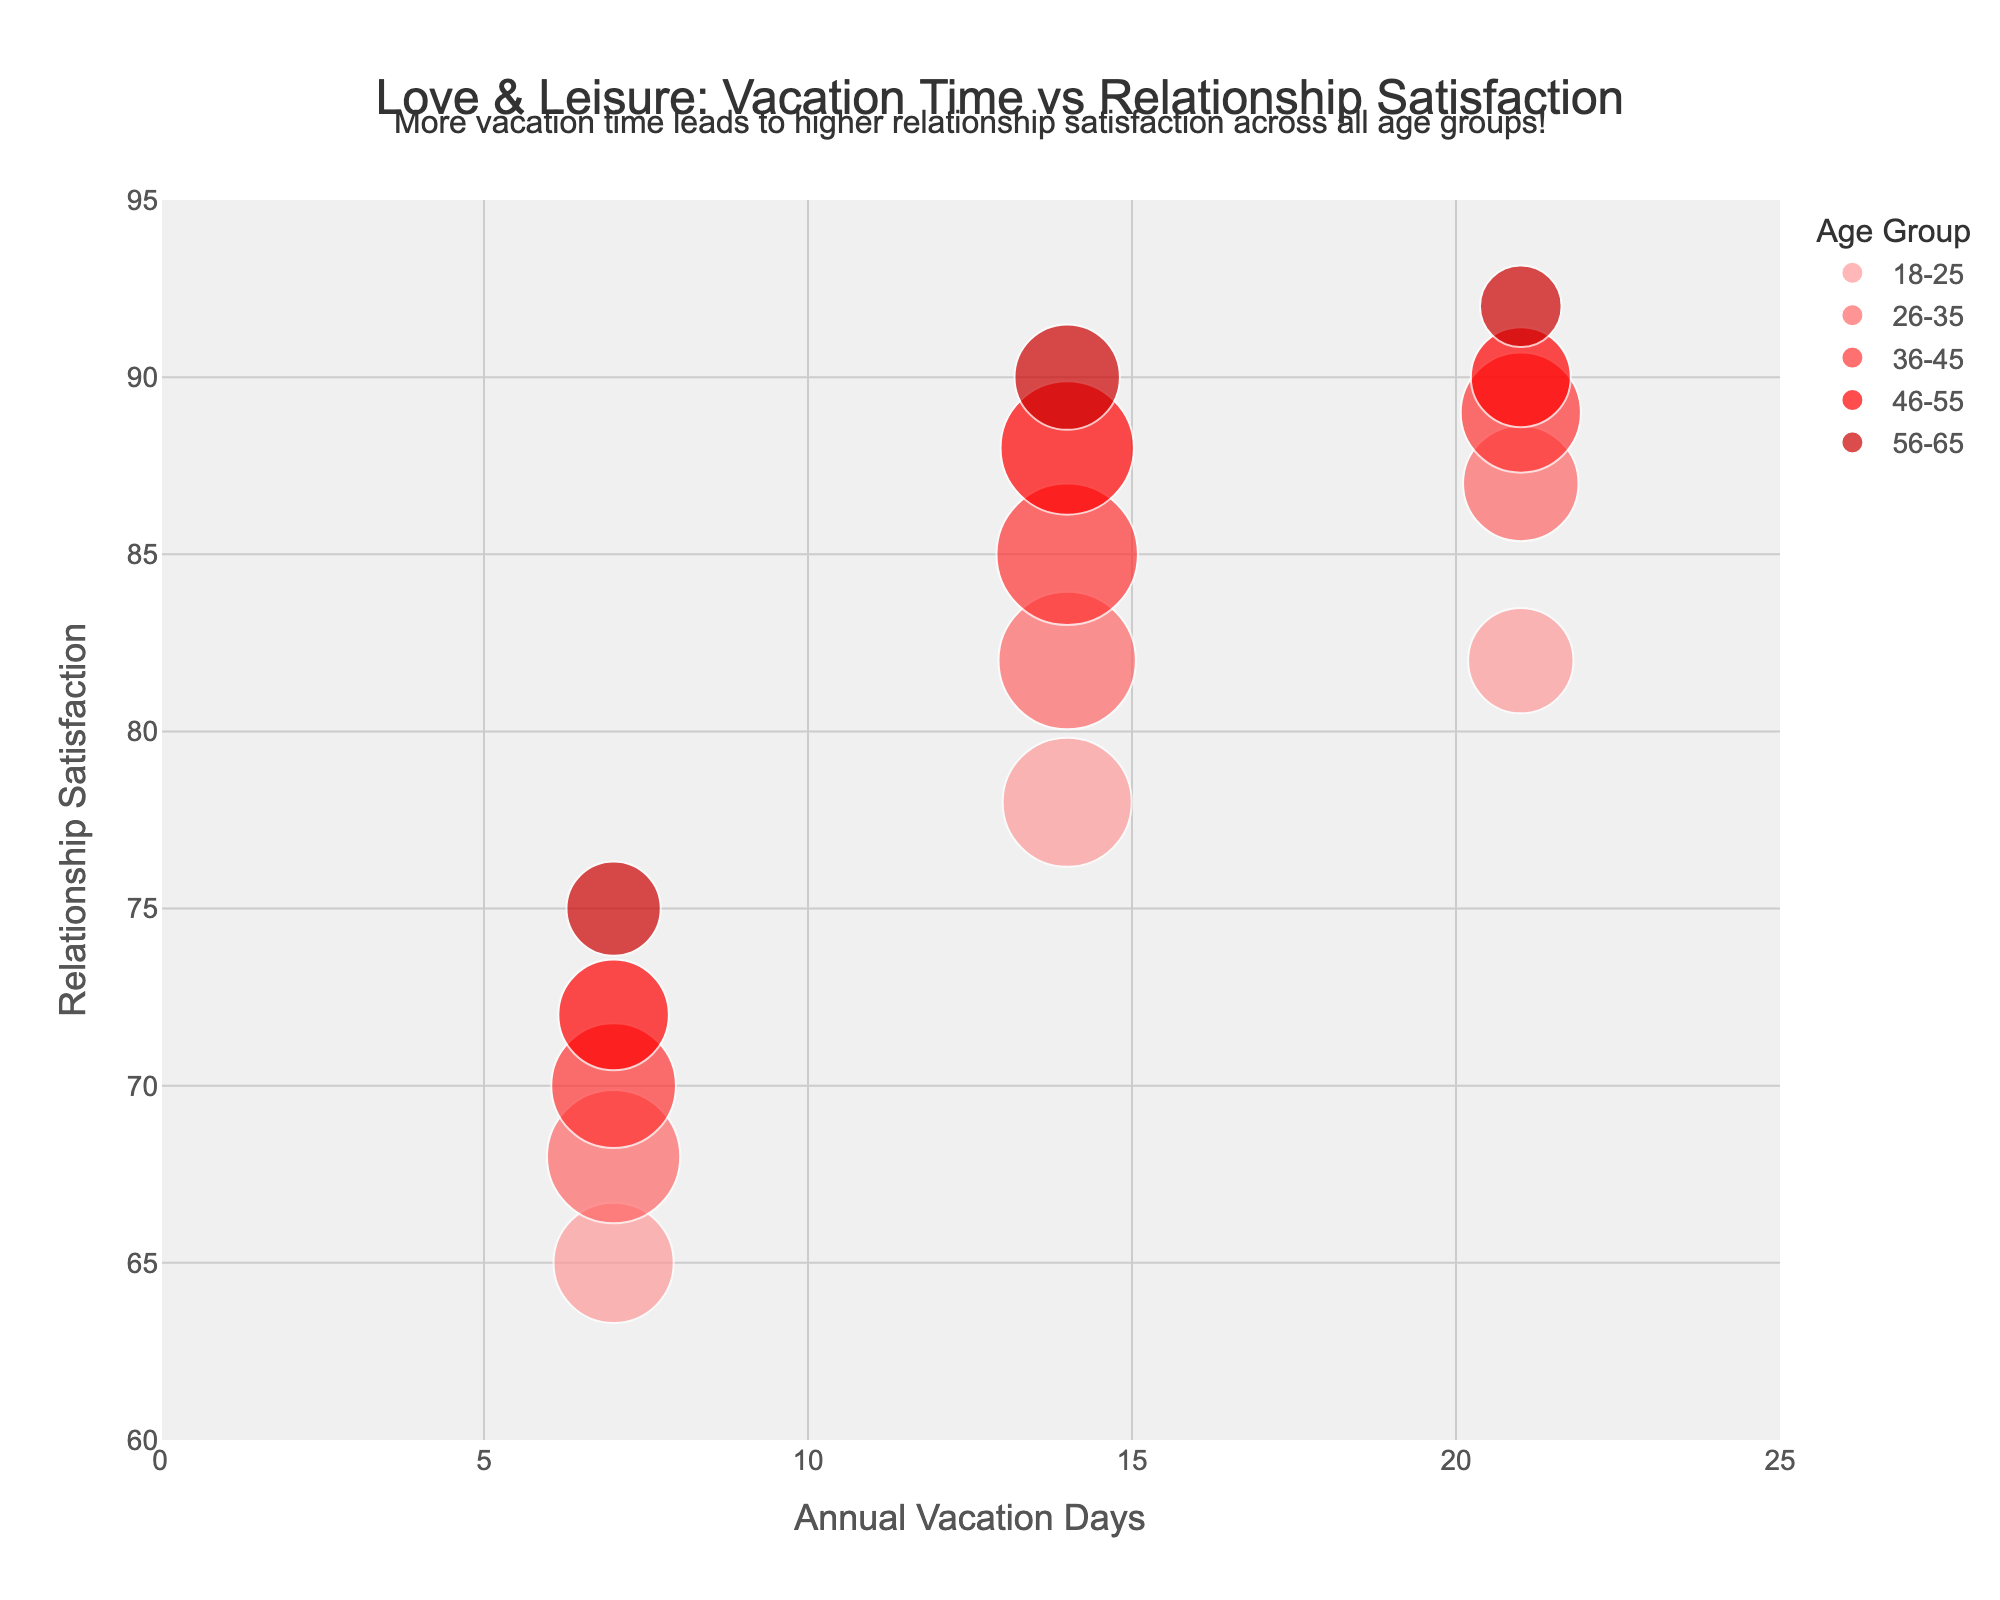What's the title of the chart? The chart title is usually prominently displayed at the top of the figure. It reads "Love & Leisure: Vacation Time vs Relationship Satisfaction".
Answer: Love & Leisure: Vacation Time vs Relationship Satisfaction What are the x and y axes of the chart? Labels at the ends of the axes provide information about what each axis represents. The x-axis is labeled "Annual Vacation Days" and the y-axis is labeled "Relationship Satisfaction".
Answer: Annual Vacation Days (x-axis) and Relationship Satisfaction (y-axis) Which age group has the highest relationship satisfaction with 21 vacation days? By looking at the y-axis value for the bubbles corresponding to 21 vacation days, you can see that the 46-55 age group has the highest relationship satisfaction at 90.
Answer: 46-55 How does relationship satisfaction change with increasing vacation days for the age group 36-45? For the 36-45 age group, the bubbles upwardly shift as vacation days increase, indicating higher relationship satisfaction.
Answer: Increases Which age group has the largest bubble size, and what does it represent? The size of the bubble correlates with the number of couples. The largest bubble in the figure belongs to the 36-45 age group for 14 vacation days, representing 180 couples.
Answer: 36-45; 180 couples Compare the relationship satisfaction for age groups 18-25 and 56-65 with 7 vacation days. Identify the y-values of the points corresponding to 7 vacation days for both age groups. The 18-25 age group has a relationship satisfaction of 65, while the 56-65 group has 75.
Answer: 56-65 has higher satisfaction Which age group shows the highest relationship satisfaction overall? By examining the highest points on the y-axis for each age group, the 56-65 age group reaches the highest relationship satisfaction score of 92.
Answer: 56-65 What trend is observed about relationship satisfaction across all age groups as vacation days increase from 7 to 21? Observe the general direction of the bubbles as vacation days increase from 7 to 21. Across all age groups, relationship satisfaction tends to increase with more vacation days.
Answer: Relationship satisfaction increases What's the relationship satisfaction for the 26-35 age group with 14 vacation days, and how many couples does it represent? Examine the bubble for the 26-35 age group at 14 vacation days. It shows a relationship satisfaction of 82 and represents 170 couples.
Answer: 82; 170 couples Is there a clear age group that benefits the most from 21 vacation days in terms of relationship satisfaction? By checking the y-values, the highest relationship satisfaction scores for 21 vacation days are quite close, but the 56-65 age group has the slight edge with 92.
Answer: 56-65 